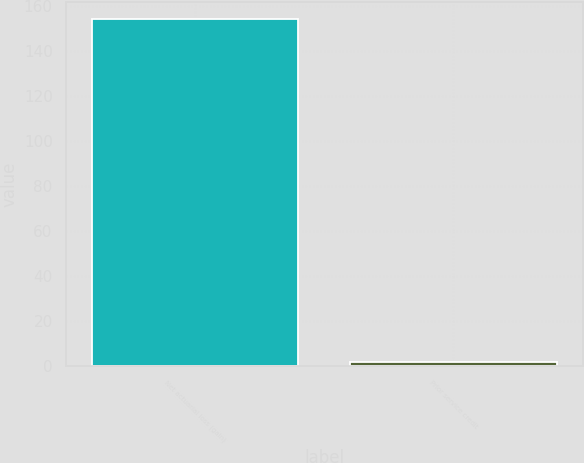Convert chart. <chart><loc_0><loc_0><loc_500><loc_500><bar_chart><fcel>Net actuarial loss (gain)<fcel>Prior service credit<nl><fcel>154<fcel>2<nl></chart> 